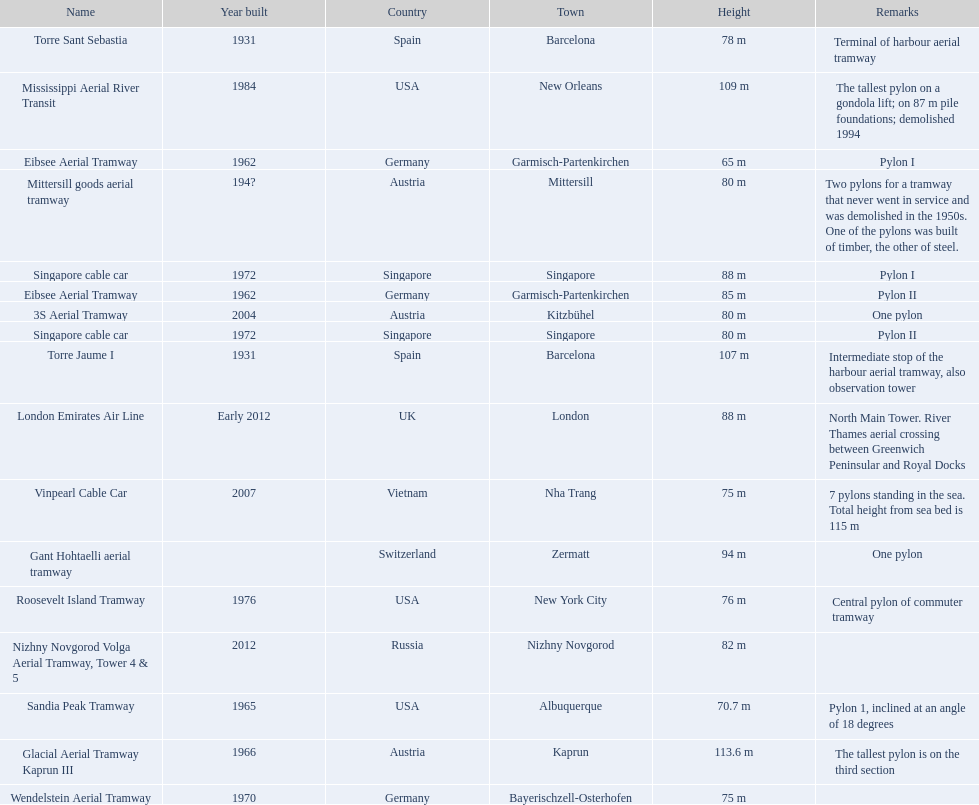Which aerial lifts are over 100 meters tall? Glacial Aerial Tramway Kaprun III, Mississippi Aerial River Transit, Torre Jaume I. Which of those was built last? Mississippi Aerial River Transit. And what is its total height? 109 m. 